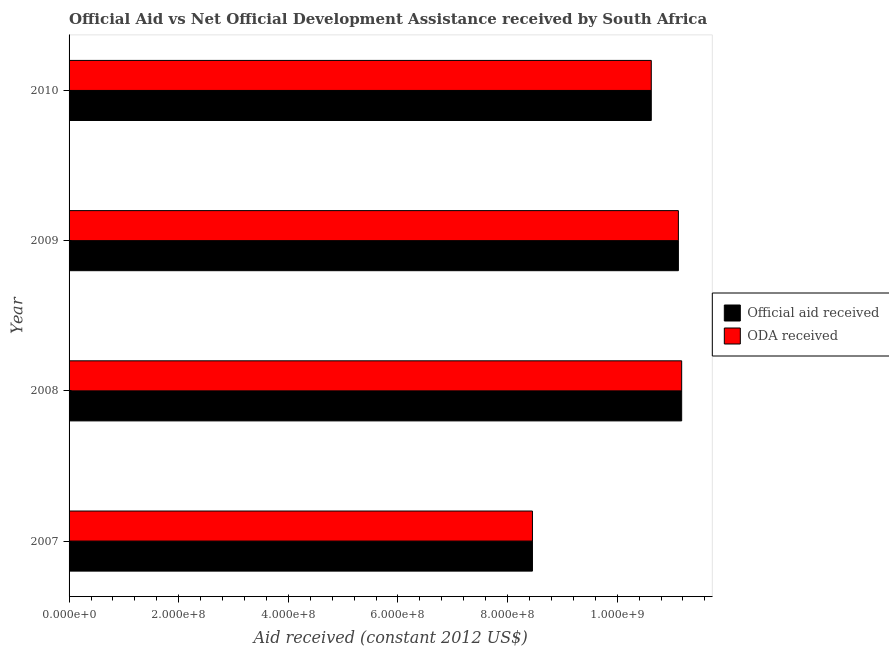Are the number of bars per tick equal to the number of legend labels?
Make the answer very short. Yes. How many bars are there on the 3rd tick from the bottom?
Provide a short and direct response. 2. In how many cases, is the number of bars for a given year not equal to the number of legend labels?
Ensure brevity in your answer.  0. What is the official aid received in 2007?
Offer a terse response. 8.45e+08. Across all years, what is the maximum official aid received?
Provide a succinct answer. 1.12e+09. Across all years, what is the minimum oda received?
Give a very brief answer. 8.45e+08. In which year was the official aid received maximum?
Make the answer very short. 2008. In which year was the official aid received minimum?
Offer a terse response. 2007. What is the total oda received in the graph?
Ensure brevity in your answer.  4.14e+09. What is the difference between the official aid received in 2008 and that in 2010?
Your answer should be very brief. 5.54e+07. What is the difference between the official aid received in 2008 and the oda received in 2010?
Your answer should be very brief. 5.54e+07. What is the average official aid received per year?
Offer a very short reply. 1.03e+09. In the year 2008, what is the difference between the oda received and official aid received?
Offer a very short reply. 0. What is the ratio of the official aid received in 2007 to that in 2008?
Your response must be concise. 0.76. Is the oda received in 2008 less than that in 2009?
Offer a very short reply. No. What is the difference between the highest and the second highest official aid received?
Offer a very short reply. 5.98e+06. What is the difference between the highest and the lowest oda received?
Keep it short and to the point. 2.72e+08. What does the 1st bar from the top in 2010 represents?
Provide a short and direct response. ODA received. What does the 1st bar from the bottom in 2007 represents?
Make the answer very short. Official aid received. Are all the bars in the graph horizontal?
Provide a short and direct response. Yes. Does the graph contain any zero values?
Ensure brevity in your answer.  No. Does the graph contain grids?
Your response must be concise. No. Where does the legend appear in the graph?
Provide a succinct answer. Center right. How many legend labels are there?
Offer a very short reply. 2. What is the title of the graph?
Give a very brief answer. Official Aid vs Net Official Development Assistance received by South Africa . Does "Electricity" appear as one of the legend labels in the graph?
Keep it short and to the point. No. What is the label or title of the X-axis?
Provide a succinct answer. Aid received (constant 2012 US$). What is the Aid received (constant 2012 US$) in Official aid received in 2007?
Provide a succinct answer. 8.45e+08. What is the Aid received (constant 2012 US$) in ODA received in 2007?
Make the answer very short. 8.45e+08. What is the Aid received (constant 2012 US$) in Official aid received in 2008?
Your response must be concise. 1.12e+09. What is the Aid received (constant 2012 US$) in ODA received in 2008?
Give a very brief answer. 1.12e+09. What is the Aid received (constant 2012 US$) in Official aid received in 2009?
Offer a very short reply. 1.11e+09. What is the Aid received (constant 2012 US$) of ODA received in 2009?
Provide a short and direct response. 1.11e+09. What is the Aid received (constant 2012 US$) of Official aid received in 2010?
Make the answer very short. 1.06e+09. What is the Aid received (constant 2012 US$) in ODA received in 2010?
Ensure brevity in your answer.  1.06e+09. Across all years, what is the maximum Aid received (constant 2012 US$) of Official aid received?
Ensure brevity in your answer.  1.12e+09. Across all years, what is the maximum Aid received (constant 2012 US$) of ODA received?
Offer a very short reply. 1.12e+09. Across all years, what is the minimum Aid received (constant 2012 US$) in Official aid received?
Keep it short and to the point. 8.45e+08. Across all years, what is the minimum Aid received (constant 2012 US$) in ODA received?
Your answer should be compact. 8.45e+08. What is the total Aid received (constant 2012 US$) of Official aid received in the graph?
Offer a very short reply. 4.14e+09. What is the total Aid received (constant 2012 US$) in ODA received in the graph?
Provide a short and direct response. 4.14e+09. What is the difference between the Aid received (constant 2012 US$) of Official aid received in 2007 and that in 2008?
Your response must be concise. -2.72e+08. What is the difference between the Aid received (constant 2012 US$) in ODA received in 2007 and that in 2008?
Offer a very short reply. -2.72e+08. What is the difference between the Aid received (constant 2012 US$) in Official aid received in 2007 and that in 2009?
Your response must be concise. -2.66e+08. What is the difference between the Aid received (constant 2012 US$) in ODA received in 2007 and that in 2009?
Your response must be concise. -2.66e+08. What is the difference between the Aid received (constant 2012 US$) of Official aid received in 2007 and that in 2010?
Provide a succinct answer. -2.17e+08. What is the difference between the Aid received (constant 2012 US$) of ODA received in 2007 and that in 2010?
Provide a short and direct response. -2.17e+08. What is the difference between the Aid received (constant 2012 US$) in Official aid received in 2008 and that in 2009?
Offer a terse response. 5.98e+06. What is the difference between the Aid received (constant 2012 US$) in ODA received in 2008 and that in 2009?
Make the answer very short. 5.98e+06. What is the difference between the Aid received (constant 2012 US$) in Official aid received in 2008 and that in 2010?
Your answer should be very brief. 5.54e+07. What is the difference between the Aid received (constant 2012 US$) in ODA received in 2008 and that in 2010?
Give a very brief answer. 5.54e+07. What is the difference between the Aid received (constant 2012 US$) in Official aid received in 2009 and that in 2010?
Offer a very short reply. 4.95e+07. What is the difference between the Aid received (constant 2012 US$) in ODA received in 2009 and that in 2010?
Provide a short and direct response. 4.95e+07. What is the difference between the Aid received (constant 2012 US$) in Official aid received in 2007 and the Aid received (constant 2012 US$) in ODA received in 2008?
Keep it short and to the point. -2.72e+08. What is the difference between the Aid received (constant 2012 US$) of Official aid received in 2007 and the Aid received (constant 2012 US$) of ODA received in 2009?
Give a very brief answer. -2.66e+08. What is the difference between the Aid received (constant 2012 US$) in Official aid received in 2007 and the Aid received (constant 2012 US$) in ODA received in 2010?
Make the answer very short. -2.17e+08. What is the difference between the Aid received (constant 2012 US$) in Official aid received in 2008 and the Aid received (constant 2012 US$) in ODA received in 2009?
Your response must be concise. 5.98e+06. What is the difference between the Aid received (constant 2012 US$) in Official aid received in 2008 and the Aid received (constant 2012 US$) in ODA received in 2010?
Your response must be concise. 5.54e+07. What is the difference between the Aid received (constant 2012 US$) in Official aid received in 2009 and the Aid received (constant 2012 US$) in ODA received in 2010?
Provide a short and direct response. 4.95e+07. What is the average Aid received (constant 2012 US$) in Official aid received per year?
Give a very brief answer. 1.03e+09. What is the average Aid received (constant 2012 US$) of ODA received per year?
Make the answer very short. 1.03e+09. In the year 2007, what is the difference between the Aid received (constant 2012 US$) in Official aid received and Aid received (constant 2012 US$) in ODA received?
Offer a very short reply. 0. In the year 2008, what is the difference between the Aid received (constant 2012 US$) of Official aid received and Aid received (constant 2012 US$) of ODA received?
Give a very brief answer. 0. In the year 2009, what is the difference between the Aid received (constant 2012 US$) of Official aid received and Aid received (constant 2012 US$) of ODA received?
Ensure brevity in your answer.  0. What is the ratio of the Aid received (constant 2012 US$) of Official aid received in 2007 to that in 2008?
Ensure brevity in your answer.  0.76. What is the ratio of the Aid received (constant 2012 US$) in ODA received in 2007 to that in 2008?
Your answer should be compact. 0.76. What is the ratio of the Aid received (constant 2012 US$) in Official aid received in 2007 to that in 2009?
Ensure brevity in your answer.  0.76. What is the ratio of the Aid received (constant 2012 US$) of ODA received in 2007 to that in 2009?
Keep it short and to the point. 0.76. What is the ratio of the Aid received (constant 2012 US$) of Official aid received in 2007 to that in 2010?
Offer a very short reply. 0.8. What is the ratio of the Aid received (constant 2012 US$) of ODA received in 2007 to that in 2010?
Keep it short and to the point. 0.8. What is the ratio of the Aid received (constant 2012 US$) of Official aid received in 2008 to that in 2009?
Provide a short and direct response. 1.01. What is the ratio of the Aid received (constant 2012 US$) in ODA received in 2008 to that in 2009?
Your answer should be compact. 1.01. What is the ratio of the Aid received (constant 2012 US$) in Official aid received in 2008 to that in 2010?
Your response must be concise. 1.05. What is the ratio of the Aid received (constant 2012 US$) of ODA received in 2008 to that in 2010?
Offer a very short reply. 1.05. What is the ratio of the Aid received (constant 2012 US$) in Official aid received in 2009 to that in 2010?
Your answer should be very brief. 1.05. What is the ratio of the Aid received (constant 2012 US$) in ODA received in 2009 to that in 2010?
Your answer should be very brief. 1.05. What is the difference between the highest and the second highest Aid received (constant 2012 US$) of Official aid received?
Your response must be concise. 5.98e+06. What is the difference between the highest and the second highest Aid received (constant 2012 US$) of ODA received?
Your answer should be compact. 5.98e+06. What is the difference between the highest and the lowest Aid received (constant 2012 US$) in Official aid received?
Make the answer very short. 2.72e+08. What is the difference between the highest and the lowest Aid received (constant 2012 US$) in ODA received?
Offer a very short reply. 2.72e+08. 